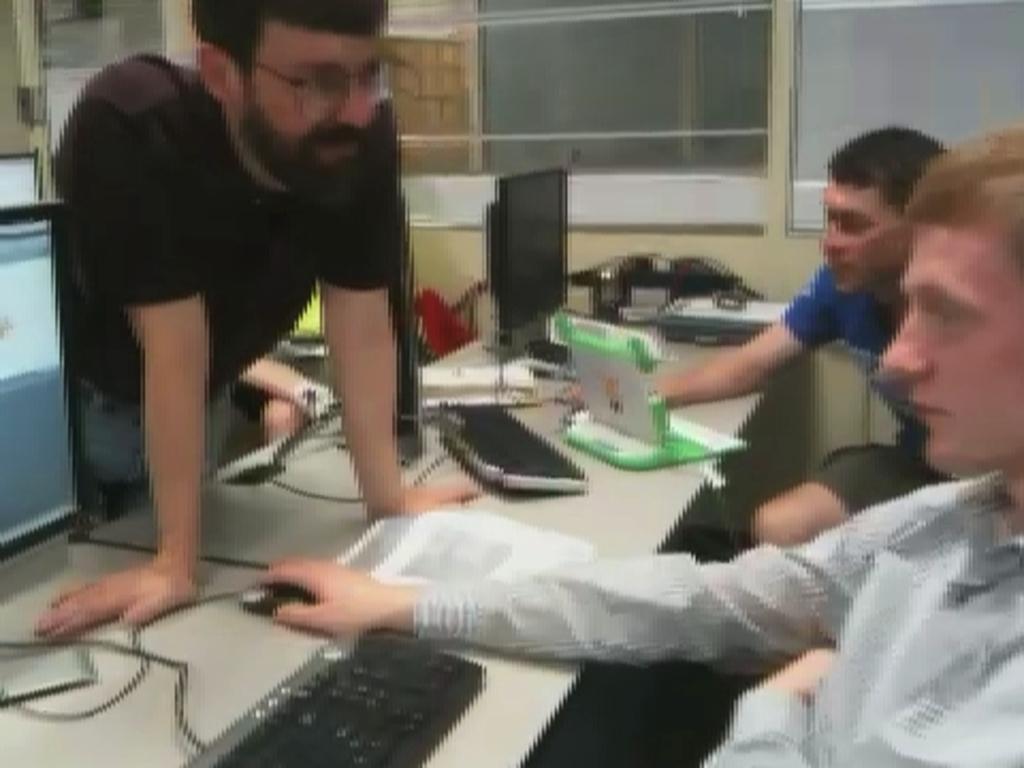Could you give a brief overview of what you see in this image? In this image we can see some persons, monitors, keyboards, mouse, table and other objects. In the background of the image there is a wall, glass window and other objects. 